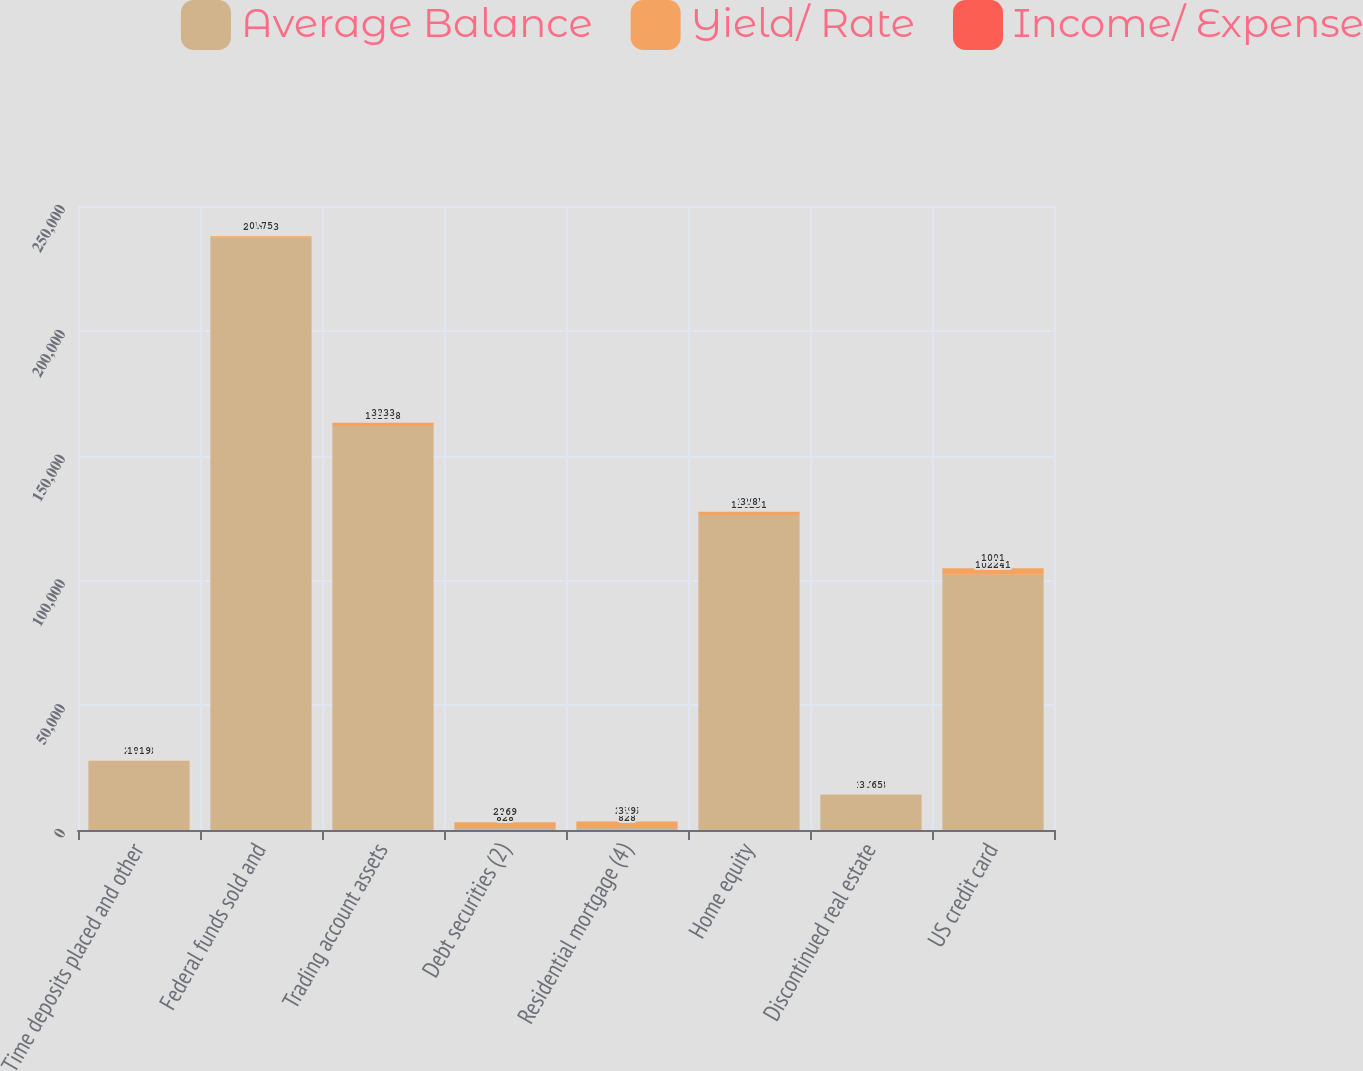<chart> <loc_0><loc_0><loc_500><loc_500><stacked_bar_chart><ecel><fcel>Time deposits placed and other<fcel>Federal funds sold and<fcel>Trading account assets<fcel>Debt securities (2)<fcel>Residential mortgage (4)<fcel>Home equity<fcel>Discontinued real estate<fcel>US credit card<nl><fcel>Average Balance<fcel>27688<fcel>237453<fcel>161848<fcel>828<fcel>828<fcel>126251<fcel>14073<fcel>102241<nl><fcel>Yield/ Rate<fcel>85<fcel>449<fcel>1354<fcel>2245<fcel>2596<fcel>1207<fcel>128<fcel>2603<nl><fcel>Income/ Expense<fcel>1.19<fcel>0.75<fcel>3.33<fcel>2.69<fcel>3.9<fcel>3.8<fcel>3.65<fcel>10.1<nl></chart> 